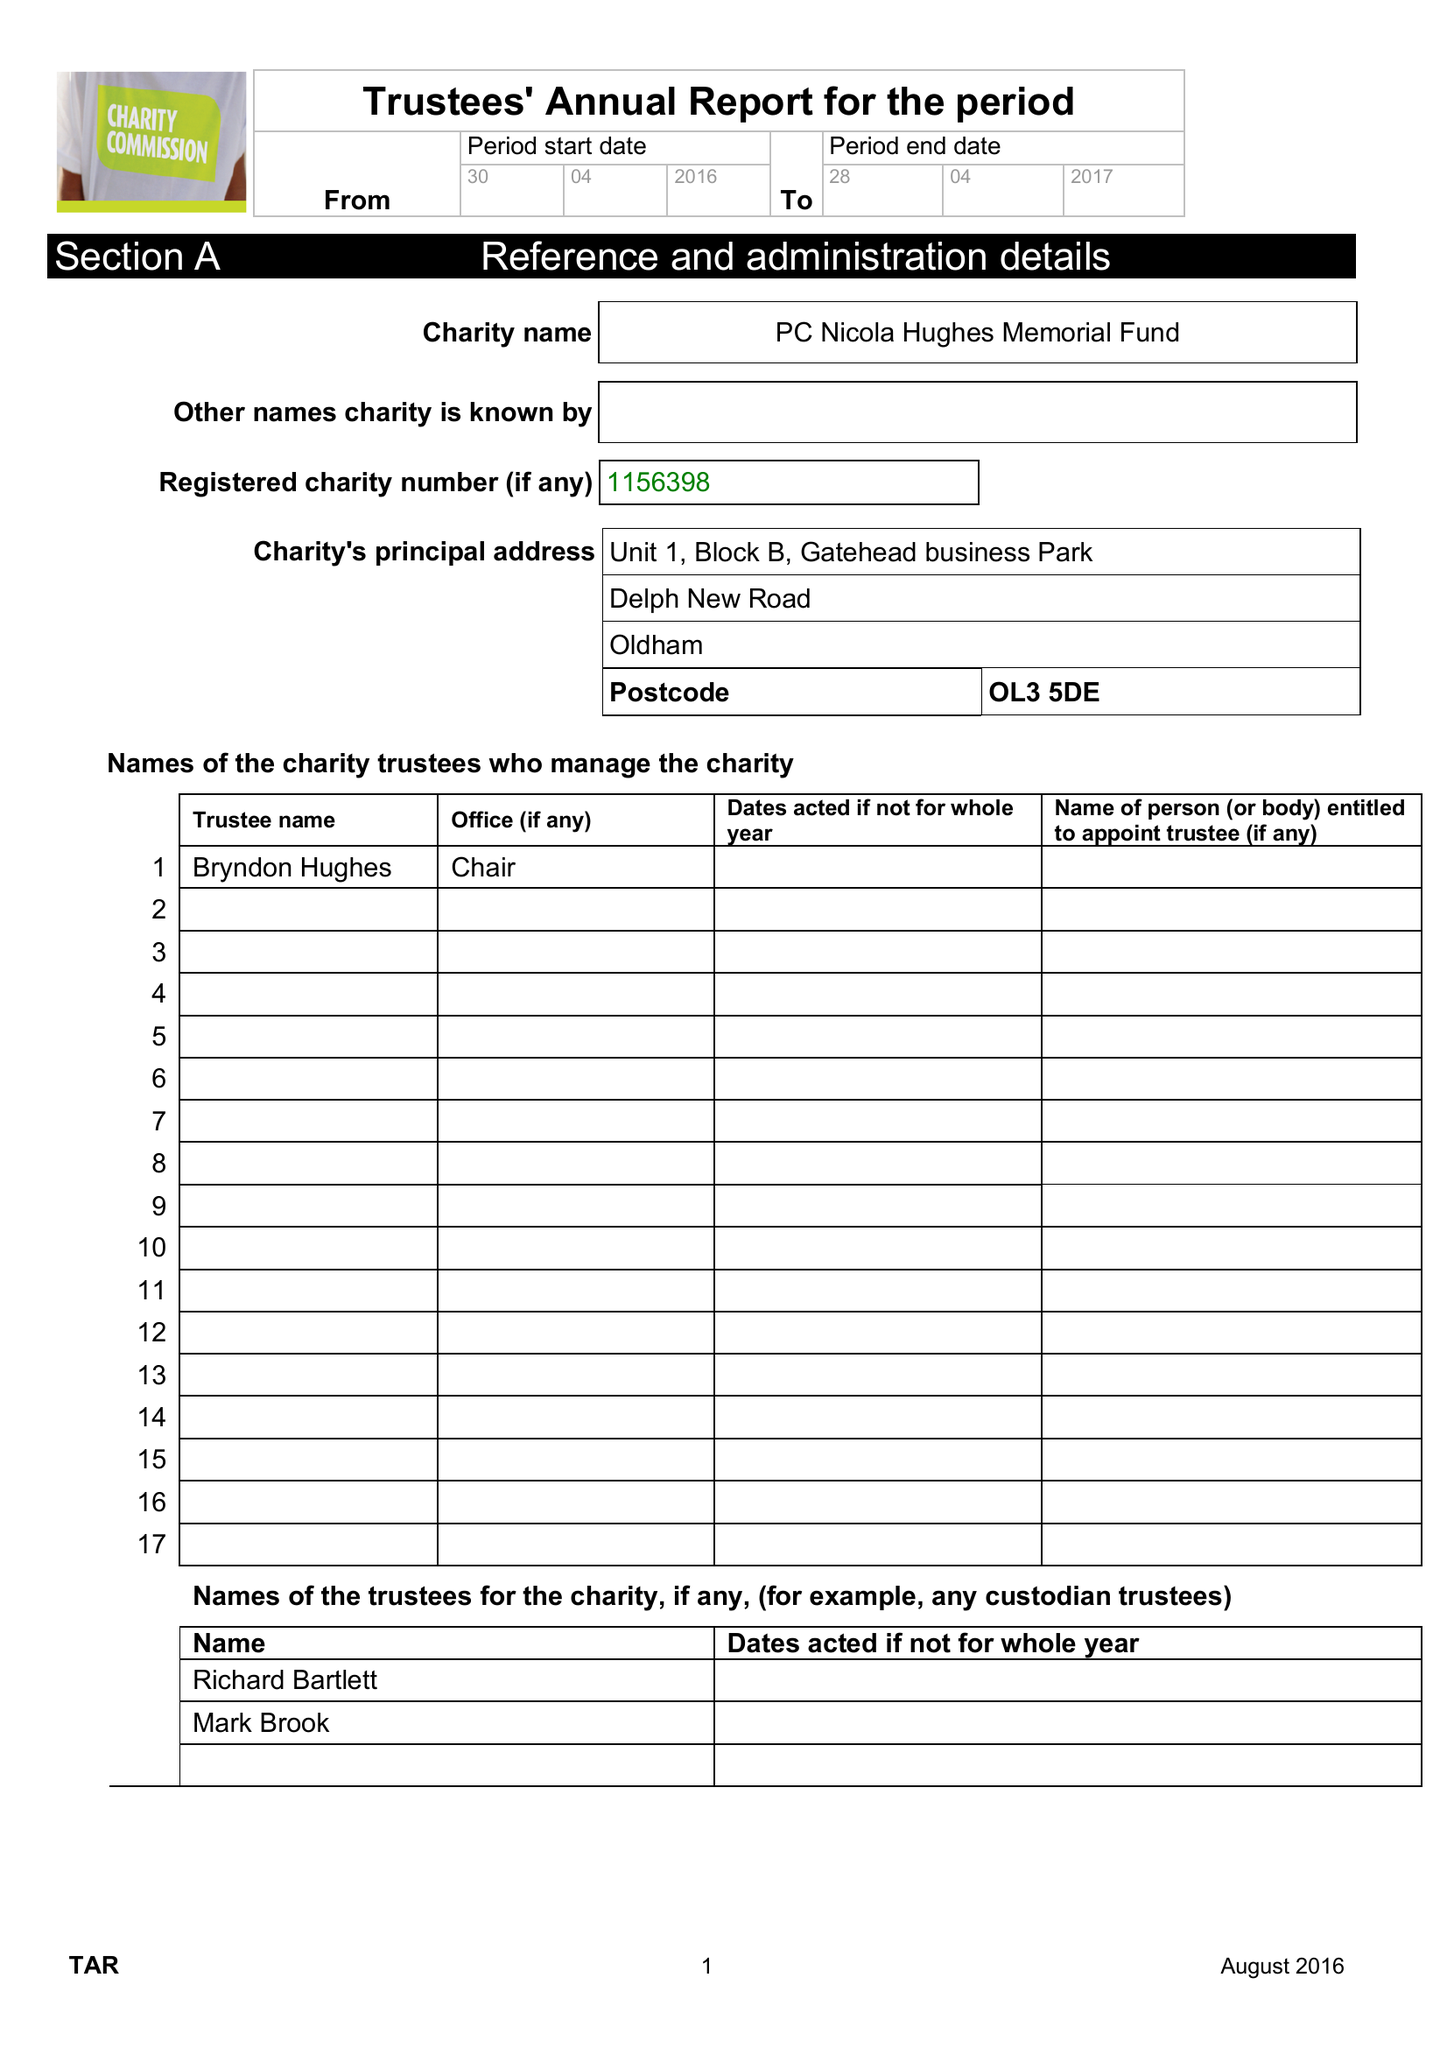What is the value for the income_annually_in_british_pounds?
Answer the question using a single word or phrase. 103373.00 